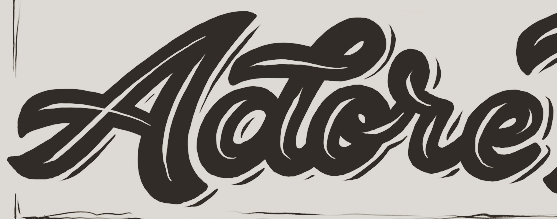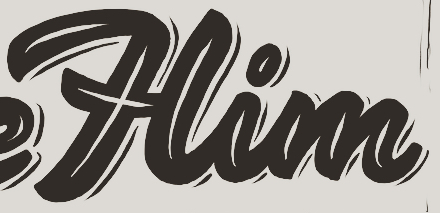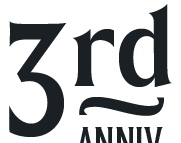What text appears in these images from left to right, separated by a semicolon? Aotore; Him; 3rd 